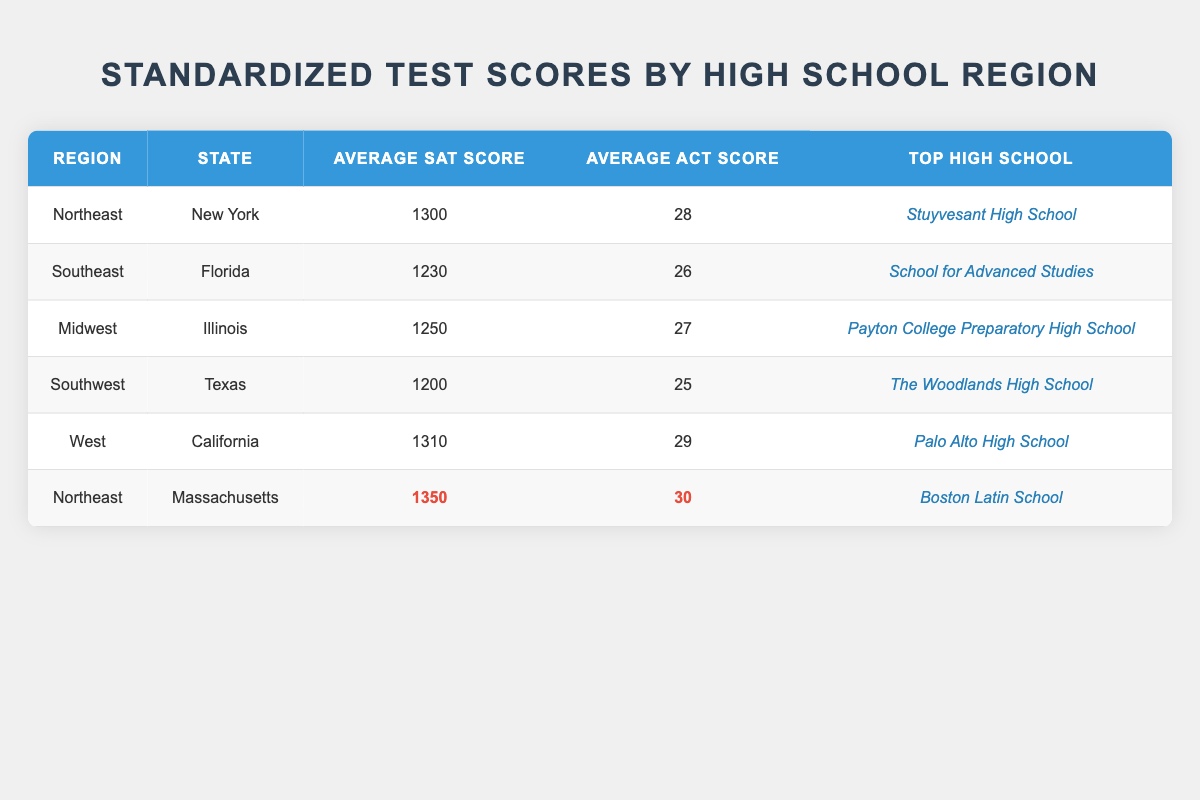What is the average SAT score in the Northeast region? The Northeast region has two entries: New York with an SAT score of 1300 and Massachusetts with an SAT score of 1350. To find the average, we add these scores together (1300 + 1350 = 2650) and divide by the number of entries (2), resulting in 2650/2 = 1325.
Answer: 1325 Which state has the highest average ACT score? Analyzing the ACT scores in the table, we have New York (28), Florida (26), Illinois (27), Texas (25), California (29), and Massachusetts (30). The highest score among these is Massachusetts at 30.
Answer: Massachusetts Is the top high school in the Midwest region the same as the top high school in the Southwest region? The top high school in the Midwest region is Payton College Preparatory High School, while in the Southwest region, it is The Woodlands High School. Since these are different schools, the answer is no.
Answer: No What is the difference between the highest and lowest average SAT scores in the table? The highest SAT score is from Massachusetts at 1350, and the lowest is from Texas at 1200. The difference is calculated as follows: 1350 - 1200 = 150.
Answer: 150 How many regions have an average ACT score of 26 or above? The regions with ACT scores of 26 or above include Northeast (28), Midwest (27), West (29), and Northeast (30 from Massachusetts). Counting these entries gives us four regions.
Answer: 4 Which region has the lowest average SAT score? Looking at the SAT scores, Texas in the Southwest region has the lowest score at 1200 compared to all other regions.
Answer: Southwest Does California have a higher average SAT score than New York? California's average SAT score is 1310, while New York's is 1300. Since 1310 is greater than 1300, California does indeed have a higher score.
Answer: Yes What is the average of the average SAT scores of the Southeast and Midwest regions? The Southeast region has an average SAT score of 1230 and the Midwest has 1250. Adding them gives 1230 + 1250 = 2480, then dividing by 2 yields 2480/2 = 1240.
Answer: 1240 How does the average ACT score from the top high school in the West compare to the overall average across all regions? The top high school in the West has an ACT score of 29. The overall average ACT score can be calculated as follows: (28 + 26 + 27 + 25 + 29 + 30) = 165, and dividing by 6 gives 165/6 = 27.5. Comparing, 29 is higher than 27.5.
Answer: Higher 